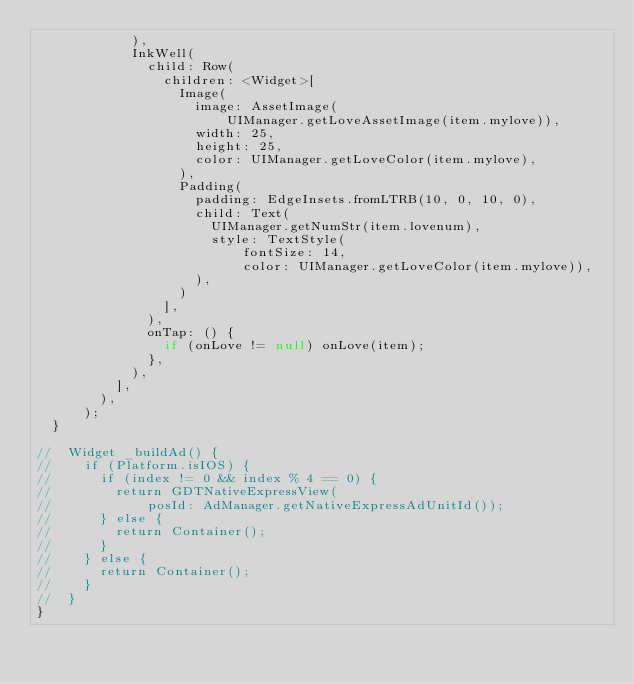<code> <loc_0><loc_0><loc_500><loc_500><_Dart_>            ),
            InkWell(
              child: Row(
                children: <Widget>[
                  Image(
                    image: AssetImage(
                        UIManager.getLoveAssetImage(item.mylove)),
                    width: 25,
                    height: 25,
                    color: UIManager.getLoveColor(item.mylove),
                  ),
                  Padding(
                    padding: EdgeInsets.fromLTRB(10, 0, 10, 0),
                    child: Text(
                      UIManager.getNumStr(item.lovenum),
                      style: TextStyle(
                          fontSize: 14,
                          color: UIManager.getLoveColor(item.mylove)),
                    ),
                  )
                ],
              ),
              onTap: () {
                if (onLove != null) onLove(item);
              },
            ),
          ],
        ),
      );
  }

//  Widget _buildAd() {
//    if (Platform.isIOS) {
//      if (index != 0 && index % 4 == 0) {
//        return GDTNativeExpressView(
//            posId: AdManager.getNativeExpressAdUnitId());
//      } else {
//        return Container();
//      }
//    } else {
//      return Container();
//    }
//  }
}
</code> 